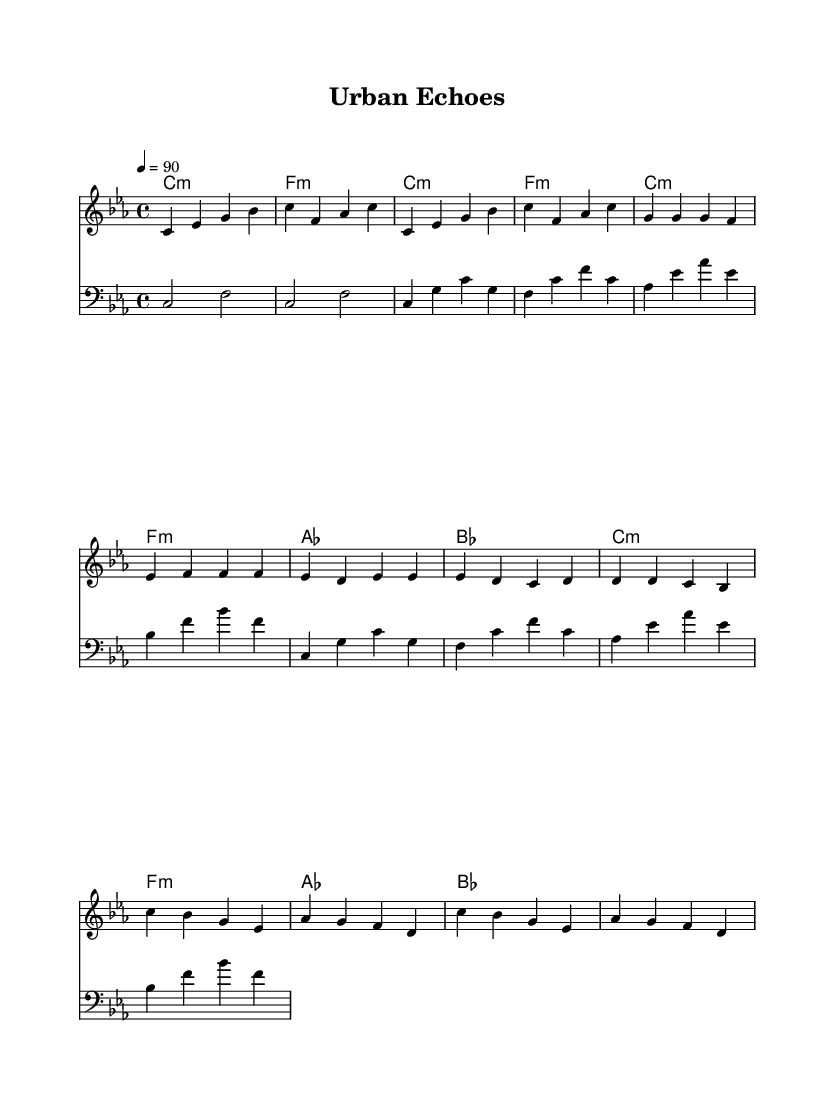What is the key signature of this music? The key signature is C minor, which has three flats (B, E, and A flat). This is identified in the sheet music by looking at the key signature on the left side, showing one flat on the bottom line for B, a flat on the third line for E, and a flat on the second space for A.
Answer: C minor What is the time signature of this music? The time signature is 4/4, which means there are four beats in each measure and the quarter note receives one beat. This is indicated at the beginning of the staff where the time signature is placed.
Answer: 4/4 What is the tempo marking for this piece? The tempo marking indicates a speed of 90 beats per minute, noted at the beginning with the text "4 = 90". This tells the musician to play at that specific speed.
Answer: 90 How many measures are there in the introduction? The introduction consists of four measures as accounted by the grouping of notes under the introductory melody section, which is clearly separated from other sections like verse and chorus.
Answer: 4 What type of chords are used in the verse? The verse features a mix of minor and major chords, specifically C minor, F minor, A major, and B flat major. This can be inferred by looking at the chord names written above the staff in the verse section.
Answer: Minor and major chords What is the structure of the song? The song is structured in an intro, verse, and chorus format, common in rap music that emphasizes a narrative or theme. This can be seen in the layout of the music, showing distinct sections labeled as such.
Answer: Intro, verse, chorus How does the bass line relate to the melody? The bass line supports the melody by outlining the harmonic structure, reinforcing the chords above while creating a rhythmic foundation. The notes in the bass line correspond to the chords labeled, and their rhythm complements the melody's phrasing.
Answer: Supports harmonic structure 